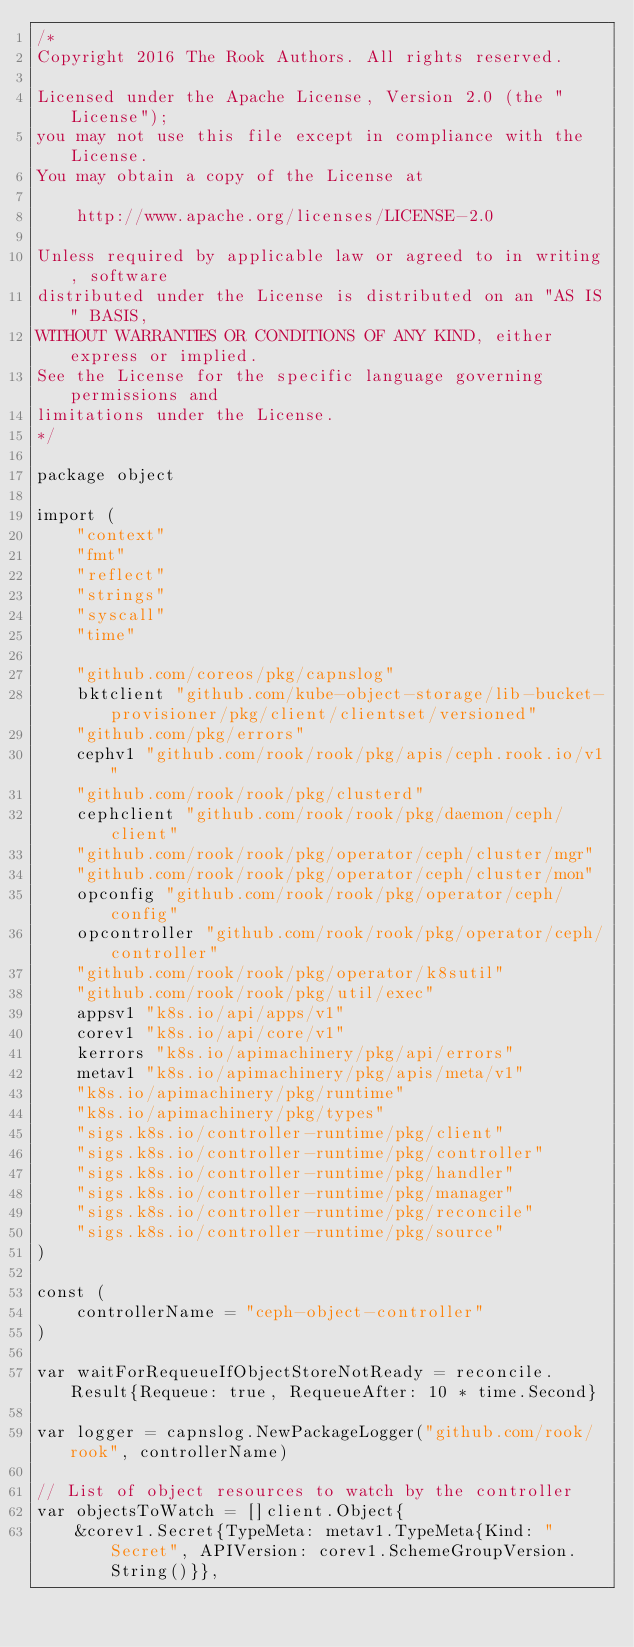<code> <loc_0><loc_0><loc_500><loc_500><_Go_>/*
Copyright 2016 The Rook Authors. All rights reserved.

Licensed under the Apache License, Version 2.0 (the "License");
you may not use this file except in compliance with the License.
You may obtain a copy of the License at

	http://www.apache.org/licenses/LICENSE-2.0

Unless required by applicable law or agreed to in writing, software
distributed under the License is distributed on an "AS IS" BASIS,
WITHOUT WARRANTIES OR CONDITIONS OF ANY KIND, either express or implied.
See the License for the specific language governing permissions and
limitations under the License.
*/

package object

import (
	"context"
	"fmt"
	"reflect"
	"strings"
	"syscall"
	"time"

	"github.com/coreos/pkg/capnslog"
	bktclient "github.com/kube-object-storage/lib-bucket-provisioner/pkg/client/clientset/versioned"
	"github.com/pkg/errors"
	cephv1 "github.com/rook/rook/pkg/apis/ceph.rook.io/v1"
	"github.com/rook/rook/pkg/clusterd"
	cephclient "github.com/rook/rook/pkg/daemon/ceph/client"
	"github.com/rook/rook/pkg/operator/ceph/cluster/mgr"
	"github.com/rook/rook/pkg/operator/ceph/cluster/mon"
	opconfig "github.com/rook/rook/pkg/operator/ceph/config"
	opcontroller "github.com/rook/rook/pkg/operator/ceph/controller"
	"github.com/rook/rook/pkg/operator/k8sutil"
	"github.com/rook/rook/pkg/util/exec"
	appsv1 "k8s.io/api/apps/v1"
	corev1 "k8s.io/api/core/v1"
	kerrors "k8s.io/apimachinery/pkg/api/errors"
	metav1 "k8s.io/apimachinery/pkg/apis/meta/v1"
	"k8s.io/apimachinery/pkg/runtime"
	"k8s.io/apimachinery/pkg/types"
	"sigs.k8s.io/controller-runtime/pkg/client"
	"sigs.k8s.io/controller-runtime/pkg/controller"
	"sigs.k8s.io/controller-runtime/pkg/handler"
	"sigs.k8s.io/controller-runtime/pkg/manager"
	"sigs.k8s.io/controller-runtime/pkg/reconcile"
	"sigs.k8s.io/controller-runtime/pkg/source"
)

const (
	controllerName = "ceph-object-controller"
)

var waitForRequeueIfObjectStoreNotReady = reconcile.Result{Requeue: true, RequeueAfter: 10 * time.Second}

var logger = capnslog.NewPackageLogger("github.com/rook/rook", controllerName)

// List of object resources to watch by the controller
var objectsToWatch = []client.Object{
	&corev1.Secret{TypeMeta: metav1.TypeMeta{Kind: "Secret", APIVersion: corev1.SchemeGroupVersion.String()}},</code> 